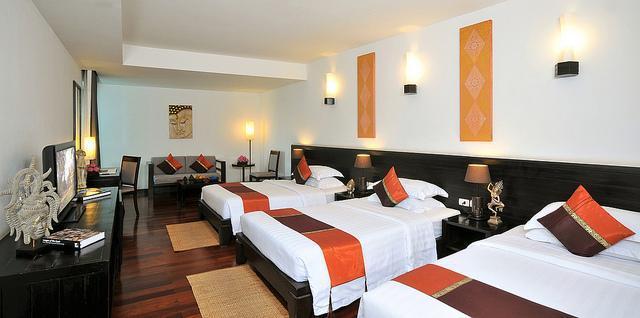How many lights are there?
Give a very brief answer. 8. How many beds are there?
Give a very brief answer. 3. 